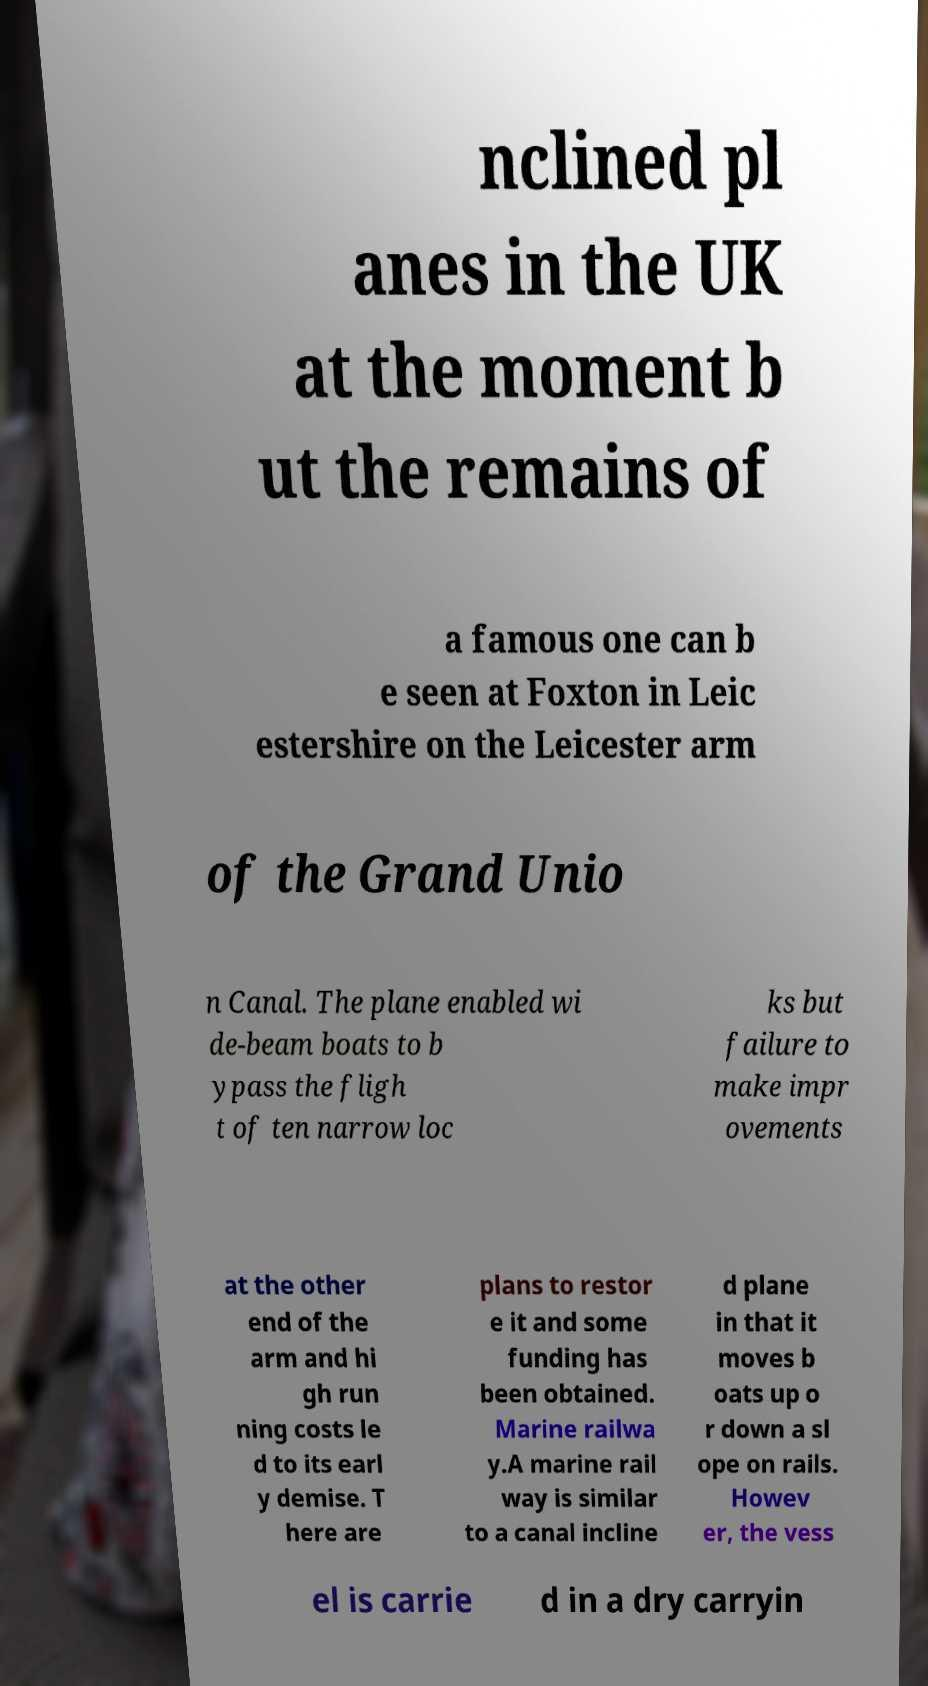Could you assist in decoding the text presented in this image and type it out clearly? nclined pl anes in the UK at the moment b ut the remains of a famous one can b e seen at Foxton in Leic estershire on the Leicester arm of the Grand Unio n Canal. The plane enabled wi de-beam boats to b ypass the fligh t of ten narrow loc ks but failure to make impr ovements at the other end of the arm and hi gh run ning costs le d to its earl y demise. T here are plans to restor e it and some funding has been obtained. Marine railwa y.A marine rail way is similar to a canal incline d plane in that it moves b oats up o r down a sl ope on rails. Howev er, the vess el is carrie d in a dry carryin 